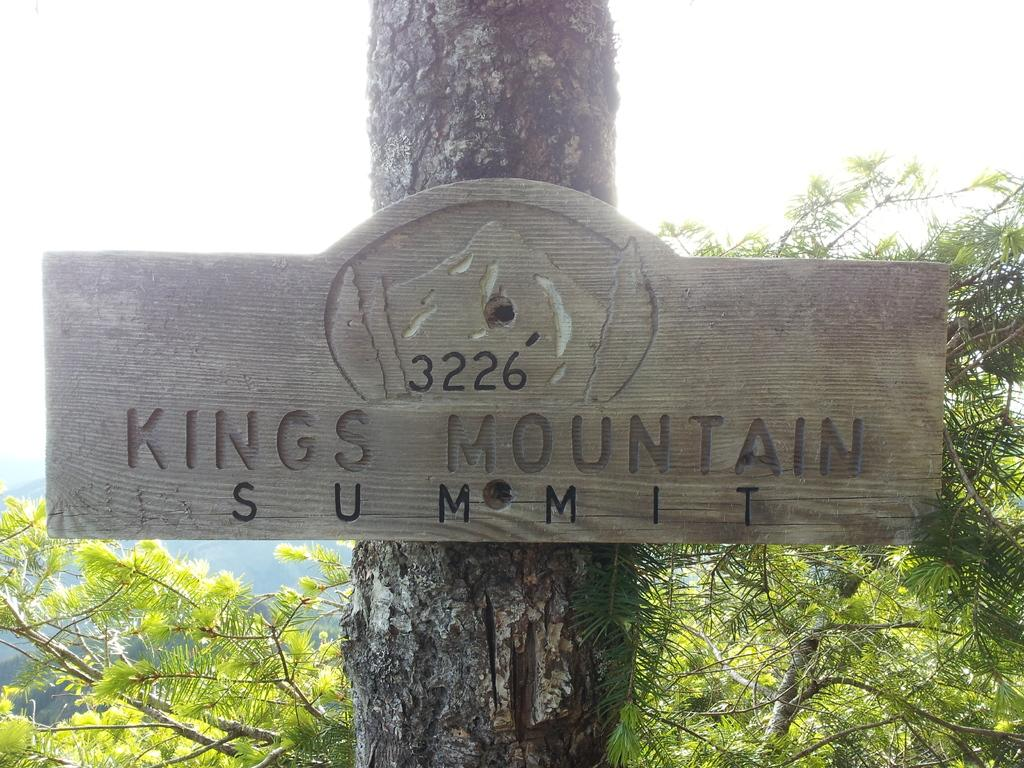What is attached to the tree trunk in the image? There is a name board attached to a tree trunk in the image. What type of vegetation can be seen at the bottom of the image? Trees are visible at the bottom of the image. What can be seen in the background of the image? The sky is visible in the background of the image. What type of silk is being used by the group of people in the image? There is no group of people or silk present in the image. 